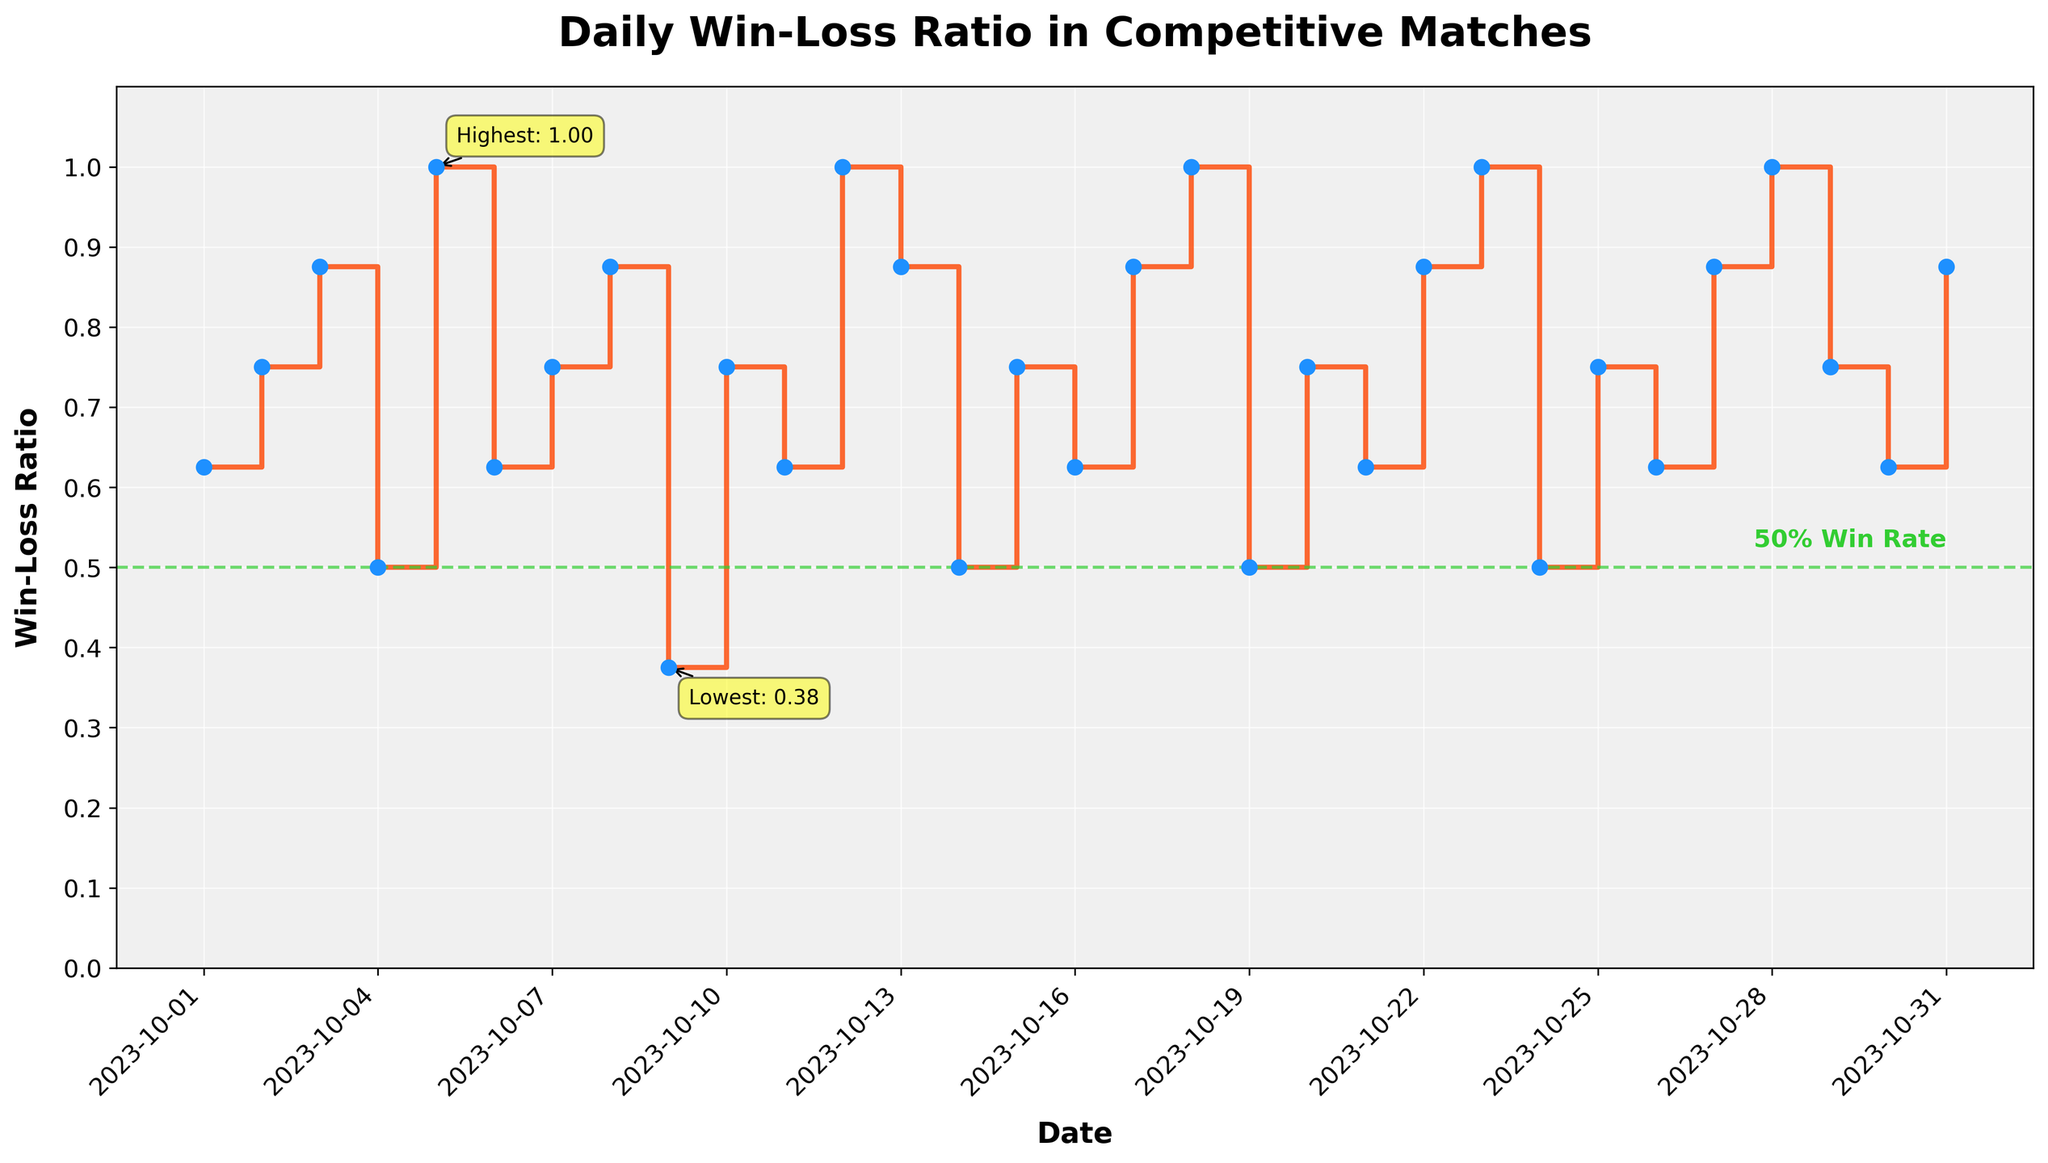What is the title of the plot? The title of the plot is typically found at the top of the figure. It summarizes what the plot is about. In this case, it is explicitly mentioned in the code used to generate the plot.
Answer: Daily Win-Loss Ratio in Competitive Matches How is the win-loss ratio on October 5th different from October 9th? To determine the difference in win-loss ratios, check the data points for October 5th and October 9th. On October 5th, the ratio is calculated as 8 wins / (8 wins + 0 losses) = 1. On October 9th, the ratio is 3 wins / (3 wins + 5 losses) = 3/8 = 0.375. Calculate the difference: 1 - 0.375 = 0.625.
Answer: 0.625 Which date has the highest win-loss ratio and what is the ratio value? From the plot, the highest point of the win-loss ratio indicates the date with the maximum value. The code annotation also mentions the highest ratio.
Answer: October 5th (or any other day where Win is 8 and Loss is 0 based on the data) What's the difference between the highest and lowest win-loss ratios? The highest ratio is 1, and the lowest ratio is 3 wins / (3 wins + 5 losses) = 3/8 = 0.375. The difference is 1 - 0.375.
Answer: 0.625 Which dates have a win-loss ratio of exactly 1? A ratio of exactly 1 occurs when the number of wins equals the total matches. In the plot, this happens when all matches are won (losses are 0).
Answer: October 5th, October 12th, October 18th, October 23rd, October 28th How many times did the win-loss ratio go below 0.5 in the month? Check the plot for points where the ratio is below 0.5. These are when the losses are higher or significant compared to wins. From the data, the specific dates should be identified where the ratio is less than 0.5.
Answer: Once (October 9th) What is the win-loss ratio on October 31st, and how does it compare to the average ratio for the month? Calculate the win-loss ratio for October 31st: 7 wins / (7 wins + 1 loss) = 7/8 = 0.875. The average ratio for the month is the mean of all individual daily ratios, calculated by summing all daily ratios and dividing by the total number of days.
Answer: October 31st is 0.875, requiring calculation for the exact average comparison Does the plot show any trend or pattern over the month? Observe the overall shape of the stair plot and any patterns in the changes in the win-loss ratio data such as cycles, steady growth, or decline.
Answer: Repetitive pattern with occasional dips below 0.5 When did the win-loss ratio drop below 0.5, and what was the exact ratio? Look for the specific date where the plot shows a drop below 0.5. From the plot annotation and data, that point can be identified.
Answer: October 9th, with a ratio of 0.375 